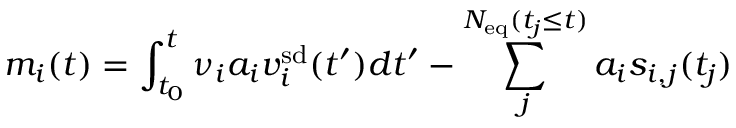<formula> <loc_0><loc_0><loc_500><loc_500>m _ { i } ( t ) = \int _ { t _ { 0 } } ^ { t } \nu _ { i } a _ { i } v _ { i } ^ { s d } ( t ^ { \prime } ) d t ^ { \prime } - \sum _ { j } ^ { N _ { e q } ( t _ { j } \leq t ) } a _ { i } s _ { i , j } ( t _ { j } )</formula> 